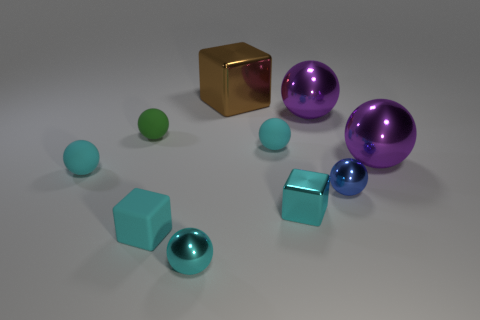What size is the green rubber ball?
Your answer should be compact. Small. What color is the metallic block that is the same size as the cyan shiny ball?
Offer a terse response. Cyan. Are there any other big cubes that have the same color as the large metal block?
Keep it short and to the point. No. What is the material of the tiny blue thing?
Your answer should be very brief. Metal. How many cyan objects are there?
Keep it short and to the point. 5. There is a ball that is behind the green rubber sphere; is it the same color as the block to the right of the brown thing?
Your answer should be compact. No. There is a shiny sphere that is the same color as the tiny metal cube; what is its size?
Offer a very short reply. Small. What number of other things are there of the same size as the matte block?
Offer a very short reply. 6. There is a ball behind the green ball; what is its color?
Offer a terse response. Purple. Is the ball on the left side of the green rubber object made of the same material as the tiny blue sphere?
Provide a short and direct response. No. 